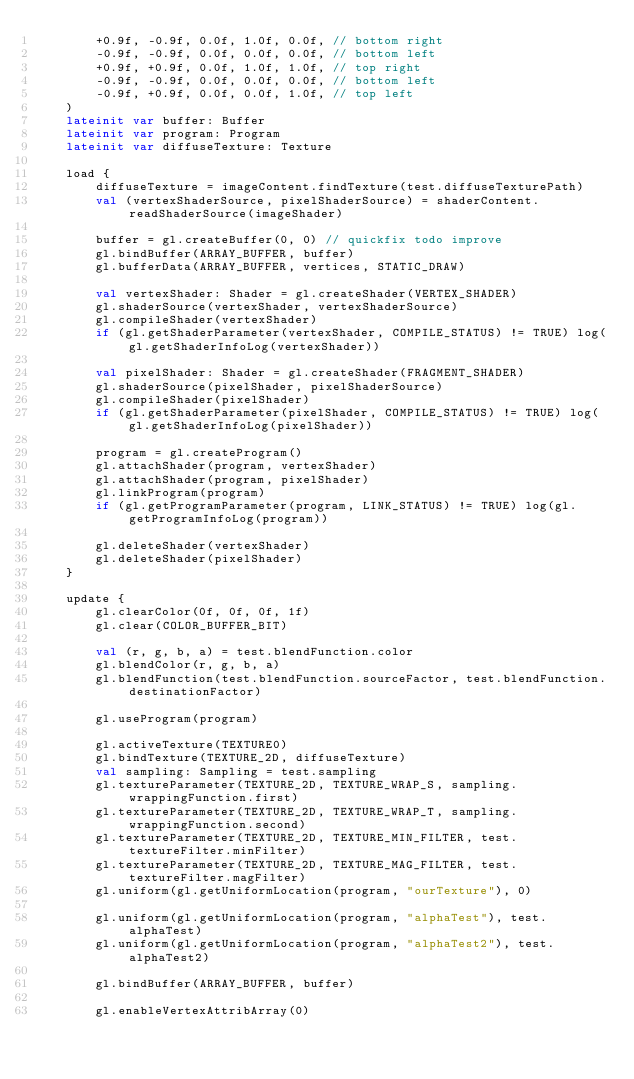<code> <loc_0><loc_0><loc_500><loc_500><_Kotlin_>        +0.9f, -0.9f, 0.0f, 1.0f, 0.0f, // bottom right
        -0.9f, -0.9f, 0.0f, 0.0f, 0.0f, // bottom left
        +0.9f, +0.9f, 0.0f, 1.0f, 1.0f, // top right
        -0.9f, -0.9f, 0.0f, 0.0f, 0.0f, // bottom left
        -0.9f, +0.9f, 0.0f, 0.0f, 1.0f, // top left
    )
    lateinit var buffer: Buffer
    lateinit var program: Program
    lateinit var diffuseTexture: Texture

    load {
        diffuseTexture = imageContent.findTexture(test.diffuseTexturePath)
        val (vertexShaderSource, pixelShaderSource) = shaderContent.readShaderSource(imageShader)

        buffer = gl.createBuffer(0, 0) // quickfix todo improve
        gl.bindBuffer(ARRAY_BUFFER, buffer)
        gl.bufferData(ARRAY_BUFFER, vertices, STATIC_DRAW)

        val vertexShader: Shader = gl.createShader(VERTEX_SHADER)
        gl.shaderSource(vertexShader, vertexShaderSource)
        gl.compileShader(vertexShader)
        if (gl.getShaderParameter(vertexShader, COMPILE_STATUS) != TRUE) log(gl.getShaderInfoLog(vertexShader))

        val pixelShader: Shader = gl.createShader(FRAGMENT_SHADER)
        gl.shaderSource(pixelShader, pixelShaderSource)
        gl.compileShader(pixelShader)
        if (gl.getShaderParameter(pixelShader, COMPILE_STATUS) != TRUE) log(gl.getShaderInfoLog(pixelShader))

        program = gl.createProgram()
        gl.attachShader(program, vertexShader)
        gl.attachShader(program, pixelShader)
        gl.linkProgram(program)
        if (gl.getProgramParameter(program, LINK_STATUS) != TRUE) log(gl.getProgramInfoLog(program))

        gl.deleteShader(vertexShader)
        gl.deleteShader(pixelShader)
    }

    update {
        gl.clearColor(0f, 0f, 0f, 1f)
        gl.clear(COLOR_BUFFER_BIT)

        val (r, g, b, a) = test.blendFunction.color
        gl.blendColor(r, g, b, a)
        gl.blendFunction(test.blendFunction.sourceFactor, test.blendFunction.destinationFactor)

        gl.useProgram(program)

        gl.activeTexture(TEXTURE0)
        gl.bindTexture(TEXTURE_2D, diffuseTexture)
        val sampling: Sampling = test.sampling
        gl.textureParameter(TEXTURE_2D, TEXTURE_WRAP_S, sampling.wrappingFunction.first)
        gl.textureParameter(TEXTURE_2D, TEXTURE_WRAP_T, sampling.wrappingFunction.second)
        gl.textureParameter(TEXTURE_2D, TEXTURE_MIN_FILTER, test.textureFilter.minFilter)
        gl.textureParameter(TEXTURE_2D, TEXTURE_MAG_FILTER, test.textureFilter.magFilter)
        gl.uniform(gl.getUniformLocation(program, "ourTexture"), 0)

        gl.uniform(gl.getUniformLocation(program, "alphaTest"), test.alphaTest)
        gl.uniform(gl.getUniformLocation(program, "alphaTest2"), test.alphaTest2)

        gl.bindBuffer(ARRAY_BUFFER, buffer)

        gl.enableVertexAttribArray(0)</code> 